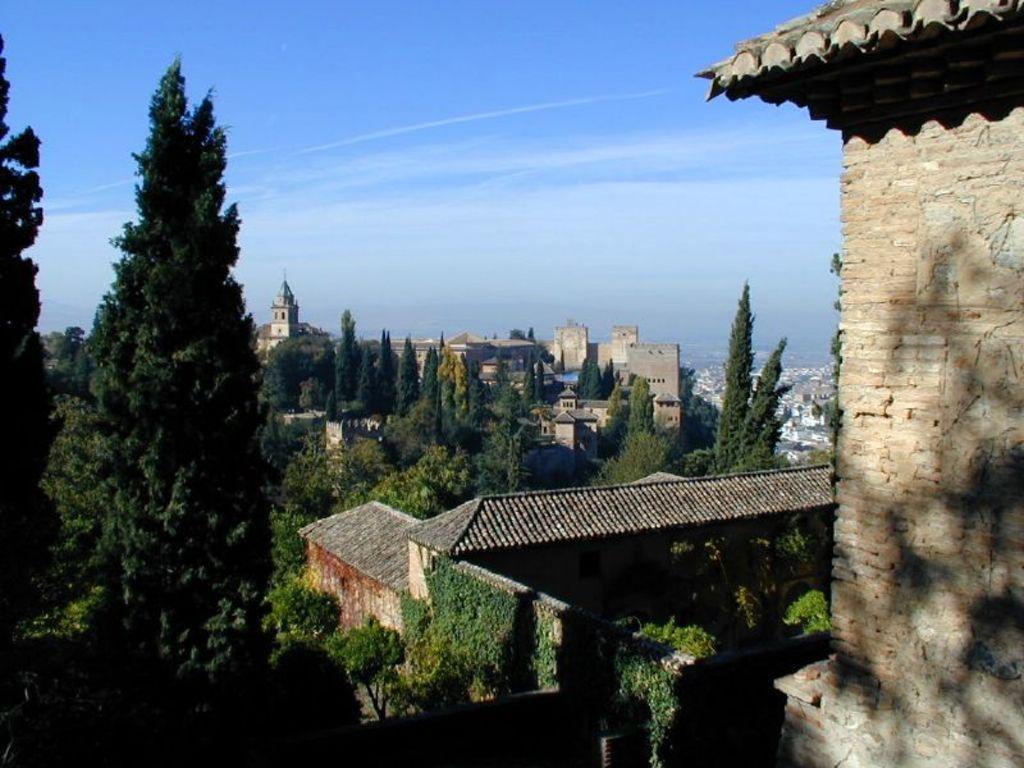Describe this image in one or two sentences. In this image we can see buildings and trees. At the top of the image, we can see the sky. 